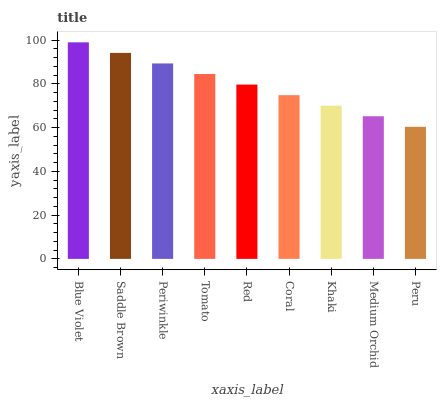Is Peru the minimum?
Answer yes or no. Yes. Is Blue Violet the maximum?
Answer yes or no. Yes. Is Saddle Brown the minimum?
Answer yes or no. No. Is Saddle Brown the maximum?
Answer yes or no. No. Is Blue Violet greater than Saddle Brown?
Answer yes or no. Yes. Is Saddle Brown less than Blue Violet?
Answer yes or no. Yes. Is Saddle Brown greater than Blue Violet?
Answer yes or no. No. Is Blue Violet less than Saddle Brown?
Answer yes or no. No. Is Red the high median?
Answer yes or no. Yes. Is Red the low median?
Answer yes or no. Yes. Is Medium Orchid the high median?
Answer yes or no. No. Is Periwinkle the low median?
Answer yes or no. No. 